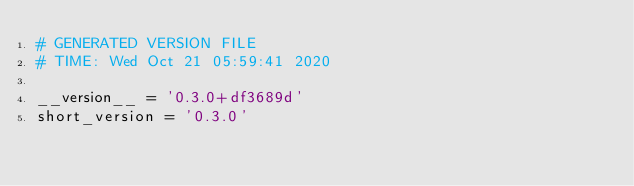<code> <loc_0><loc_0><loc_500><loc_500><_Python_># GENERATED VERSION FILE
# TIME: Wed Oct 21 05:59:41 2020

__version__ = '0.3.0+df3689d'
short_version = '0.3.0'
</code> 